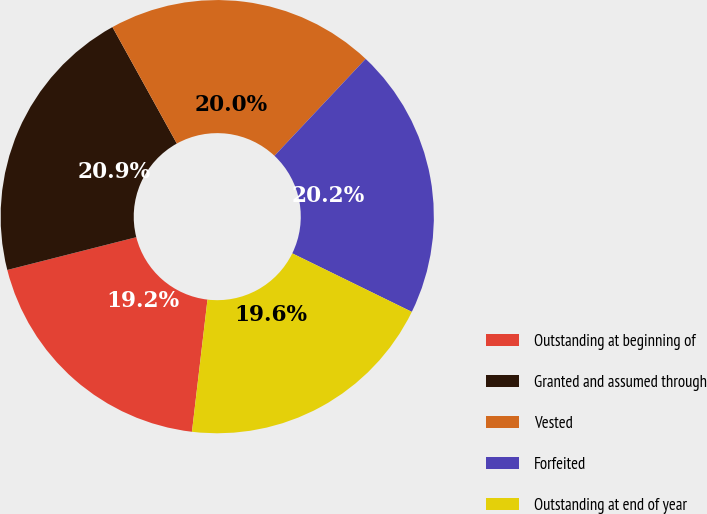Convert chart to OTSL. <chart><loc_0><loc_0><loc_500><loc_500><pie_chart><fcel>Outstanding at beginning of<fcel>Granted and assumed through<fcel>Vested<fcel>Forfeited<fcel>Outstanding at end of year<nl><fcel>19.18%<fcel>20.92%<fcel>20.05%<fcel>20.23%<fcel>19.62%<nl></chart> 